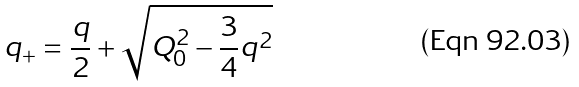<formula> <loc_0><loc_0><loc_500><loc_500>q _ { + } = \frac { q } { 2 } + \sqrt { Q ^ { 2 } _ { 0 } - \frac { 3 } { 4 } q ^ { 2 } }</formula> 